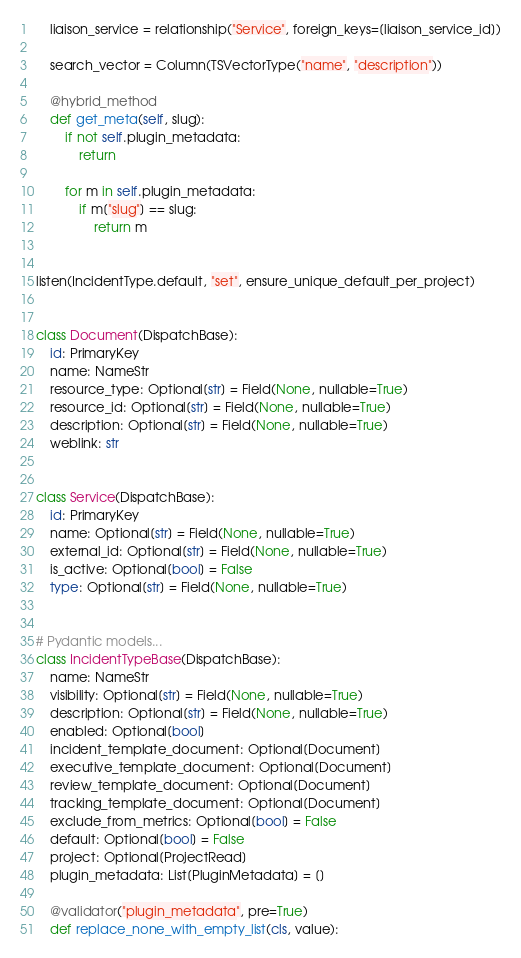<code> <loc_0><loc_0><loc_500><loc_500><_Python_>    liaison_service = relationship("Service", foreign_keys=[liaison_service_id])

    search_vector = Column(TSVectorType("name", "description"))

    @hybrid_method
    def get_meta(self, slug):
        if not self.plugin_metadata:
            return

        for m in self.plugin_metadata:
            if m["slug"] == slug:
                return m


listen(IncidentType.default, "set", ensure_unique_default_per_project)


class Document(DispatchBase):
    id: PrimaryKey
    name: NameStr
    resource_type: Optional[str] = Field(None, nullable=True)
    resource_id: Optional[str] = Field(None, nullable=True)
    description: Optional[str] = Field(None, nullable=True)
    weblink: str


class Service(DispatchBase):
    id: PrimaryKey
    name: Optional[str] = Field(None, nullable=True)
    external_id: Optional[str] = Field(None, nullable=True)
    is_active: Optional[bool] = False
    type: Optional[str] = Field(None, nullable=True)


# Pydantic models...
class IncidentTypeBase(DispatchBase):
    name: NameStr
    visibility: Optional[str] = Field(None, nullable=True)
    description: Optional[str] = Field(None, nullable=True)
    enabled: Optional[bool]
    incident_template_document: Optional[Document]
    executive_template_document: Optional[Document]
    review_template_document: Optional[Document]
    tracking_template_document: Optional[Document]
    exclude_from_metrics: Optional[bool] = False
    default: Optional[bool] = False
    project: Optional[ProjectRead]
    plugin_metadata: List[PluginMetadata] = []

    @validator("plugin_metadata", pre=True)
    def replace_none_with_empty_list(cls, value):</code> 